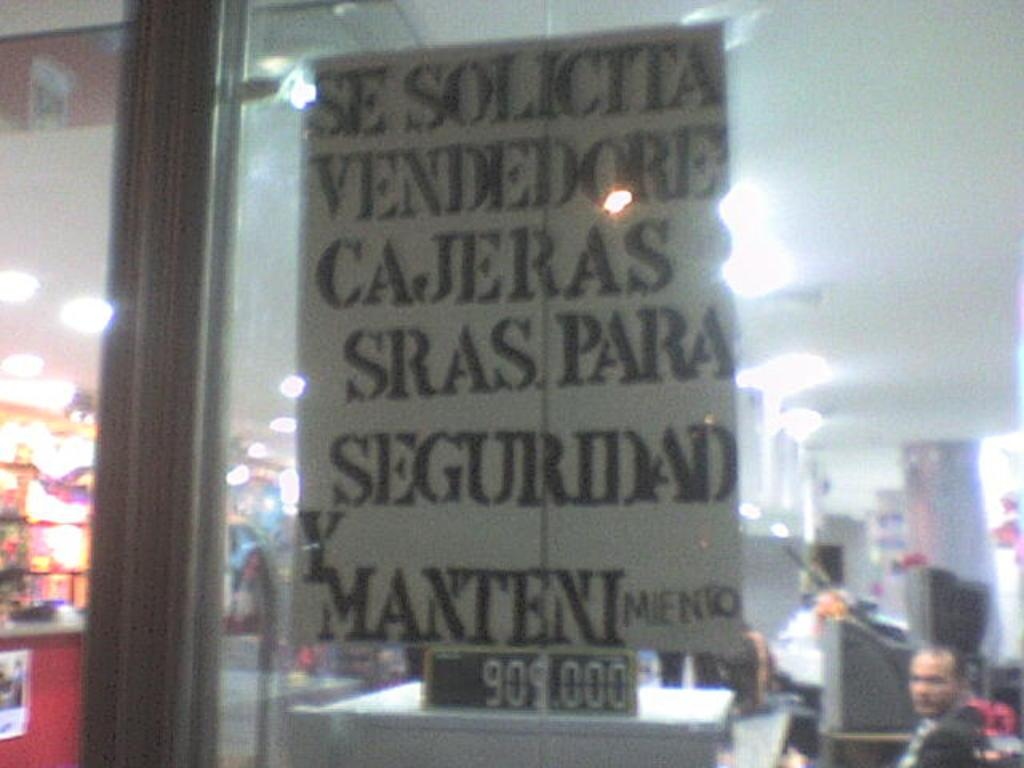What can be seen in the image that is typically used for drinking? There is a glass in the image that is typically used for drinking. Can you describe the person visible inside the building? There is a person visible inside the building, but their appearance or actions are not described in the facts. What type of objects can be seen inside the building? There are many objects inside the building, but their specific types are not described in the facts. What type of signage or display is visible inside the building? There are boards visible inside the building, but their content or purpose is not described in the facts. What type of illumination is visible inside the building? There are lights visible inside the building, but their specific type or intensity is not described in the facts. What type of quince is being used to decorate the building in the image? There is no mention of quince or any type of decoration in the image. 